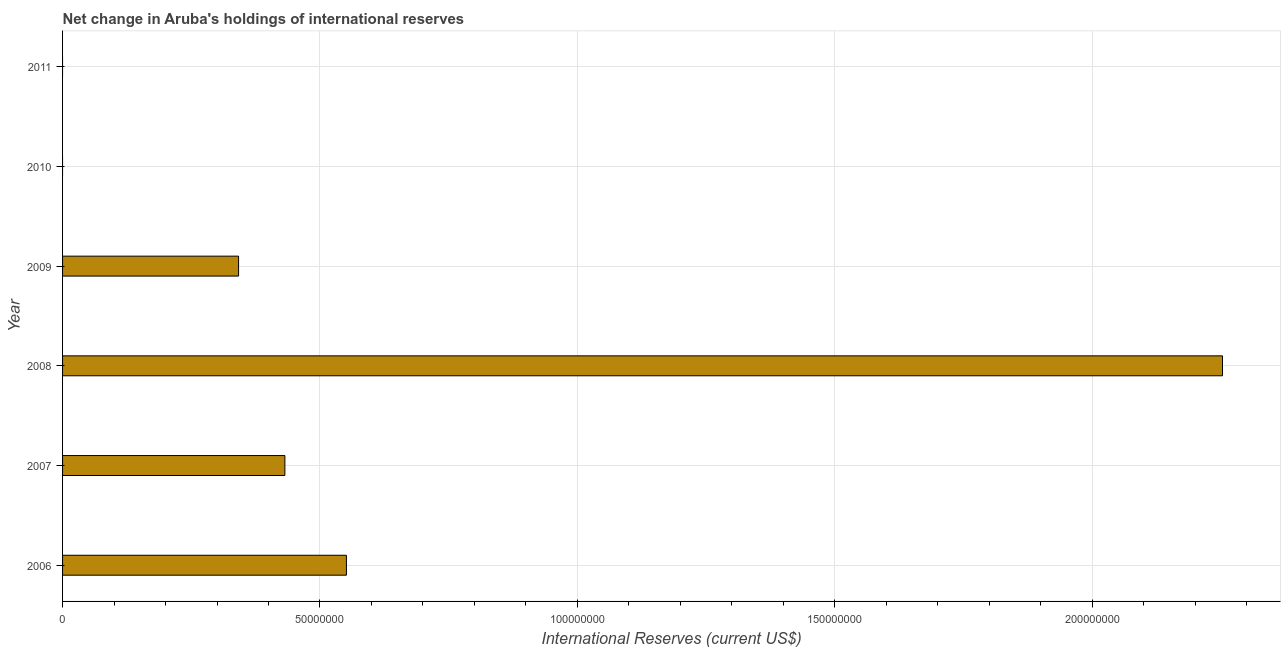Does the graph contain any zero values?
Offer a very short reply. Yes. Does the graph contain grids?
Offer a very short reply. Yes. What is the title of the graph?
Your answer should be compact. Net change in Aruba's holdings of international reserves. What is the label or title of the X-axis?
Keep it short and to the point. International Reserves (current US$). What is the reserves and related items in 2011?
Provide a short and direct response. 0. Across all years, what is the maximum reserves and related items?
Provide a succinct answer. 2.25e+08. Across all years, what is the minimum reserves and related items?
Provide a short and direct response. 0. What is the sum of the reserves and related items?
Offer a very short reply. 3.58e+08. What is the difference between the reserves and related items in 2008 and 2009?
Provide a short and direct response. 1.91e+08. What is the average reserves and related items per year?
Your response must be concise. 5.96e+07. What is the median reserves and related items?
Give a very brief answer. 3.87e+07. In how many years, is the reserves and related items greater than 100000000 US$?
Ensure brevity in your answer.  1. What is the ratio of the reserves and related items in 2006 to that in 2008?
Your answer should be very brief. 0.24. Is the reserves and related items in 2007 less than that in 2009?
Give a very brief answer. No. Is the difference between the reserves and related items in 2006 and 2009 greater than the difference between any two years?
Your response must be concise. No. What is the difference between the highest and the second highest reserves and related items?
Make the answer very short. 1.70e+08. What is the difference between the highest and the lowest reserves and related items?
Your response must be concise. 2.25e+08. Are all the bars in the graph horizontal?
Offer a terse response. Yes. What is the difference between two consecutive major ticks on the X-axis?
Make the answer very short. 5.00e+07. What is the International Reserves (current US$) of 2006?
Your response must be concise. 5.51e+07. What is the International Reserves (current US$) of 2007?
Your response must be concise. 4.32e+07. What is the International Reserves (current US$) of 2008?
Provide a short and direct response. 2.25e+08. What is the International Reserves (current US$) in 2009?
Make the answer very short. 3.42e+07. What is the difference between the International Reserves (current US$) in 2006 and 2007?
Your answer should be compact. 1.20e+07. What is the difference between the International Reserves (current US$) in 2006 and 2008?
Give a very brief answer. -1.70e+08. What is the difference between the International Reserves (current US$) in 2006 and 2009?
Ensure brevity in your answer.  2.09e+07. What is the difference between the International Reserves (current US$) in 2007 and 2008?
Give a very brief answer. -1.82e+08. What is the difference between the International Reserves (current US$) in 2007 and 2009?
Ensure brevity in your answer.  8.99e+06. What is the difference between the International Reserves (current US$) in 2008 and 2009?
Make the answer very short. 1.91e+08. What is the ratio of the International Reserves (current US$) in 2006 to that in 2007?
Provide a succinct answer. 1.28. What is the ratio of the International Reserves (current US$) in 2006 to that in 2008?
Your response must be concise. 0.24. What is the ratio of the International Reserves (current US$) in 2006 to that in 2009?
Offer a terse response. 1.61. What is the ratio of the International Reserves (current US$) in 2007 to that in 2008?
Give a very brief answer. 0.19. What is the ratio of the International Reserves (current US$) in 2007 to that in 2009?
Provide a short and direct response. 1.26. What is the ratio of the International Reserves (current US$) in 2008 to that in 2009?
Your answer should be very brief. 6.59. 